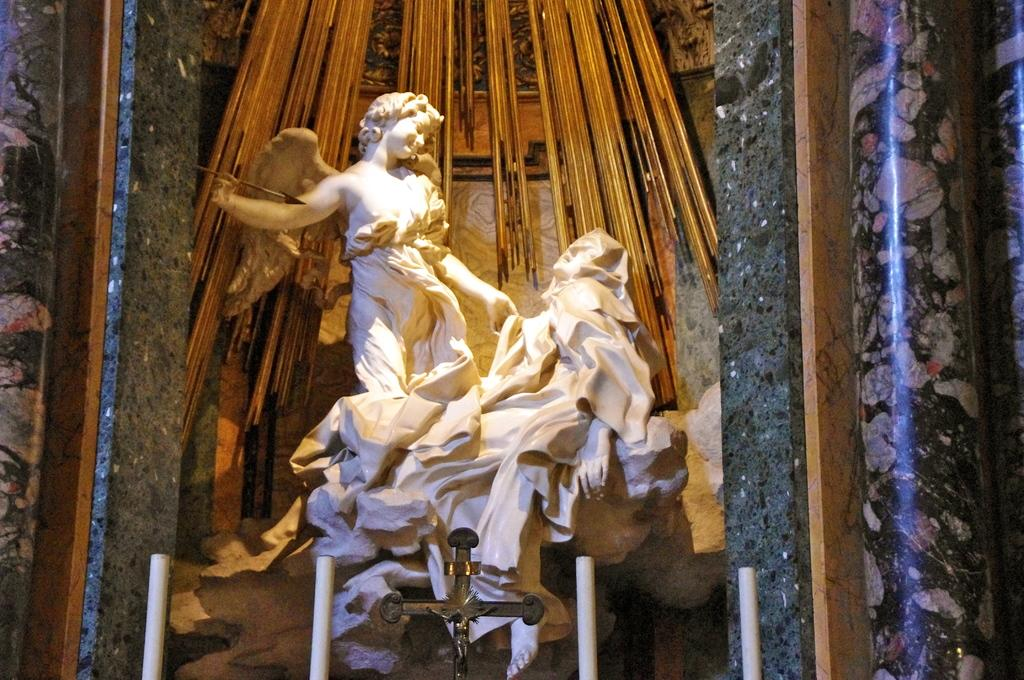What type of objects can be seen in the image? There are sculptures in the image. What type of oatmeal is being served in the image? There is no oatmeal present in the image; it only features sculptures. Can you tell me how many cows are visible in the image? There are no cows visible in the image; it only features sculptures. 